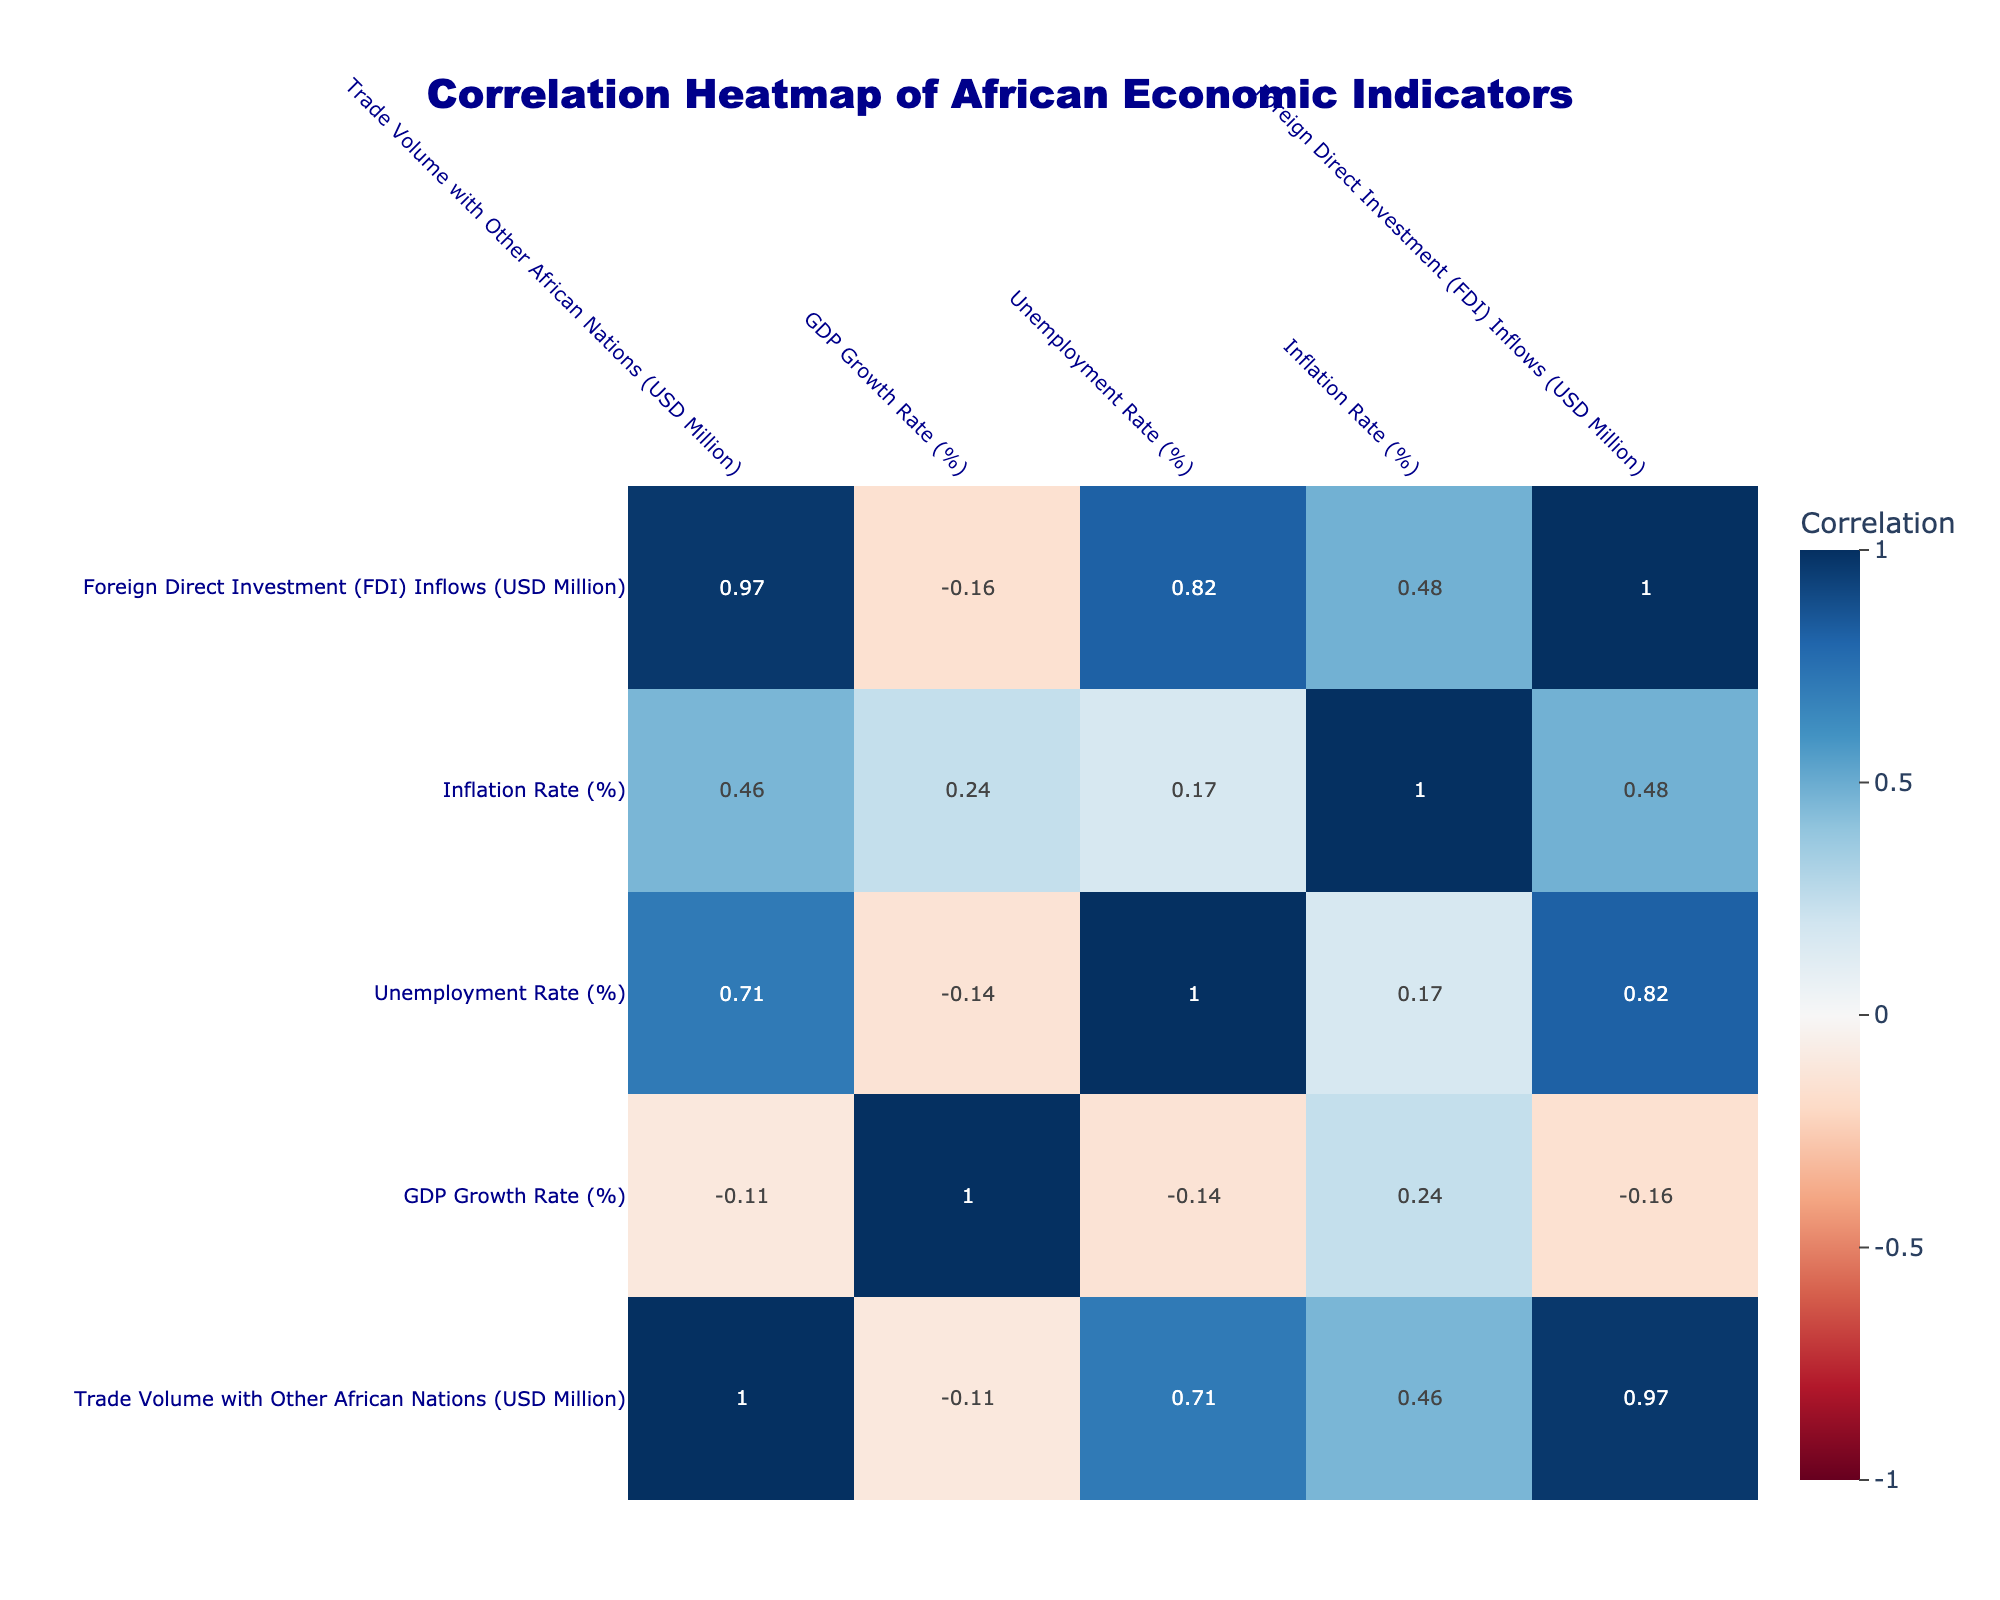What is the GDP growth rate of Nigeria? From the table, we can see the row for Nigeria which lists the GDP growth rate as 3.2%. Therefore, this is the answer.
Answer: 3.2% What is the unemployment rate for Ghana? Looking at the table, the unemployment rate listed for Ghana is 4.7%. This provides the specific value requested.
Answer: 4.7% Which country has the highest inflation rate? Examining the inflation rates in the table, Ethiopia has the highest rate at 20.0%. Therefore, that's the answer.
Answer: Ethiopia What is the average GDP growth rate of the countries listed? We sum the GDP growth rates: (3.2 + 1.9 + 5.4 + 3.5 + 6.5 + 6.1 + 5.8 + 4.6 + 7.8 - 4.0) = 37.8. There are 10 data points, so the average is 37.8 / 10 = 3.78%.
Answer: 3.78% Does Kenya have a higher trade volume with other African nations than Egypt? The trade volume for Kenya is 6000 million and for Egypt, it’s 8000 million. Since 6000 is less than 8000, the answer to this question is no.
Answer: No Is Zimbabwe experiencing positive economic conditions based on its GDP growth rate? According to the table, Zimbabwe has a GDP growth rate of -4.0%, indicating negative economic conditions. Therefore, the answer is no.
Answer: No What is the difference in trade volume between South Africa and Uganda? The trade volume for South Africa is 9000 million, while for Uganda it’s 3000 million. The difference is 9000 - 3000 = 6000 million.
Answer: 6000 million Which country shows the least foreign direct investment inflows? By checking the FDI inflows, we see that Rwanda has the least at 300 million. So, we can conclude that Rwanda has the lowest inflows.
Answer: Rwanda What is the correlation between trade volume and unemployment rate based on the table? To determine the correlation, look at the correlation matrix. Since we do not have the actual matrix values here, I can't give you the exact number. This would require referencing the heatmap generated from the correlation matrix analysis.
Answer: (Requires matrix reference) 